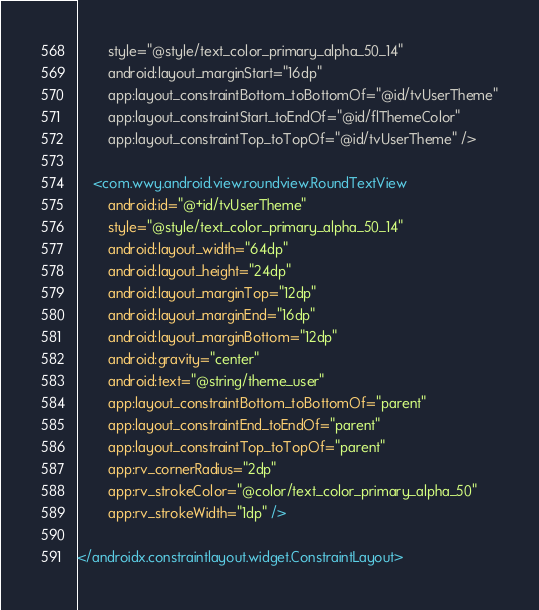Convert code to text. <code><loc_0><loc_0><loc_500><loc_500><_XML_>        style="@style/text_color_primary_alpha_50_14"
        android:layout_marginStart="16dp"
        app:layout_constraintBottom_toBottomOf="@id/tvUserTheme"
        app:layout_constraintStart_toEndOf="@id/flThemeColor"
        app:layout_constraintTop_toTopOf="@id/tvUserTheme" />

    <com.wwy.android.view.roundview.RoundTextView
        android:id="@+id/tvUserTheme"
        style="@style/text_color_primary_alpha_50_14"
        android:layout_width="64dp"
        android:layout_height="24dp"
        android:layout_marginTop="12dp"
        android:layout_marginEnd="16dp"
        android:layout_marginBottom="12dp"
        android:gravity="center"
        android:text="@string/theme_user"
        app:layout_constraintBottom_toBottomOf="parent"
        app:layout_constraintEnd_toEndOf="parent"
        app:layout_constraintTop_toTopOf="parent"
        app:rv_cornerRadius="2dp"
        app:rv_strokeColor="@color/text_color_primary_alpha_50"
        app:rv_strokeWidth="1dp" />

</androidx.constraintlayout.widget.ConstraintLayout></code> 